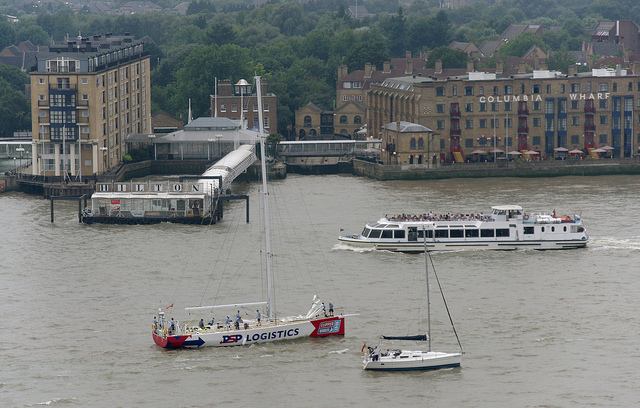Please transcribe the text information in this image. WHARE COLUMBIA HILTON LOGISTICS 